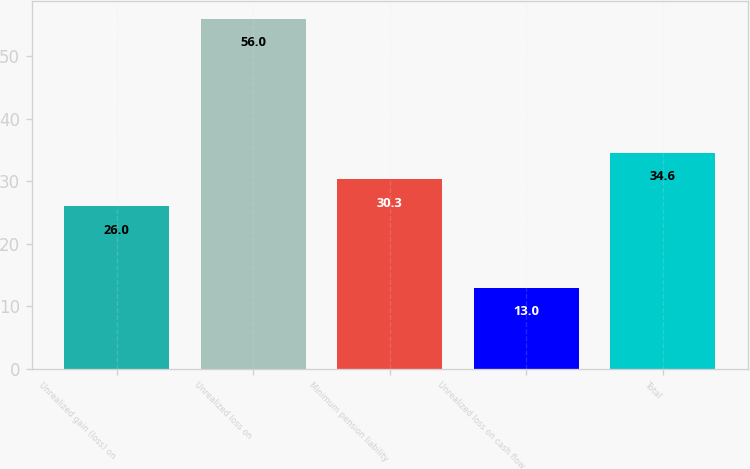<chart> <loc_0><loc_0><loc_500><loc_500><bar_chart><fcel>Unrealized gain (loss) on<fcel>Unrealized loss on<fcel>Minimum pension liability<fcel>Unrealized loss on cash flow<fcel>Total<nl><fcel>26<fcel>56<fcel>30.3<fcel>13<fcel>34.6<nl></chart> 